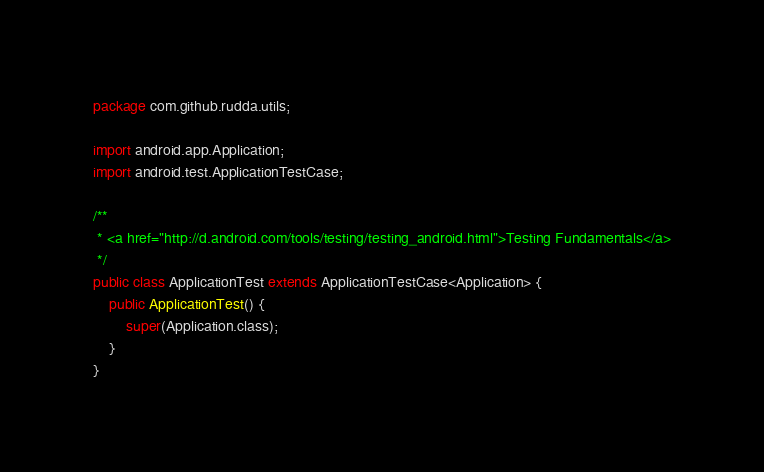Convert code to text. <code><loc_0><loc_0><loc_500><loc_500><_Java_>package com.github.rudda.utils;

import android.app.Application;
import android.test.ApplicationTestCase;

/**
 * <a href="http://d.android.com/tools/testing/testing_android.html">Testing Fundamentals</a>
 */
public class ApplicationTest extends ApplicationTestCase<Application> {
    public ApplicationTest() {
        super(Application.class);
    }
}</code> 